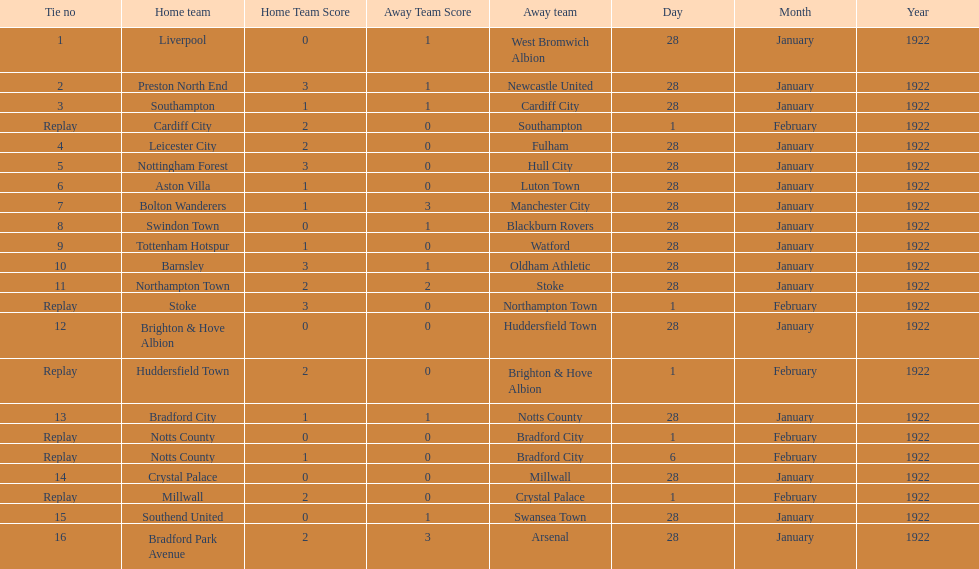What date did they play before feb 1? 28 January 1922. 